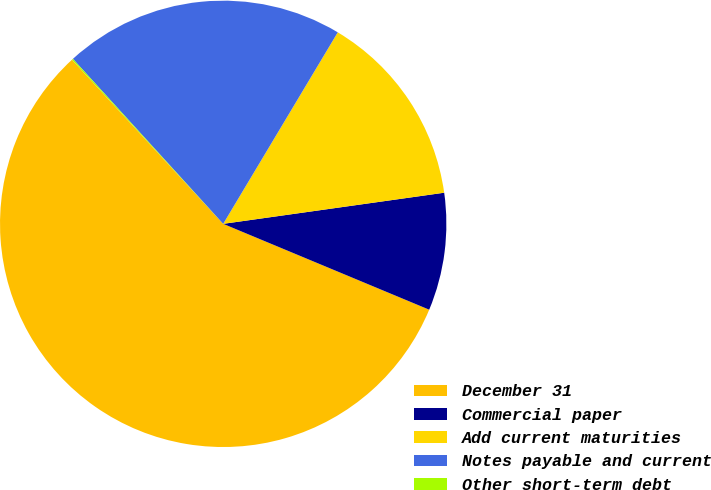<chart> <loc_0><loc_0><loc_500><loc_500><pie_chart><fcel>December 31<fcel>Commercial paper<fcel>Add current maturities<fcel>Notes payable and current<fcel>Other short-term debt<nl><fcel>56.86%<fcel>8.51%<fcel>14.19%<fcel>20.34%<fcel>0.09%<nl></chart> 